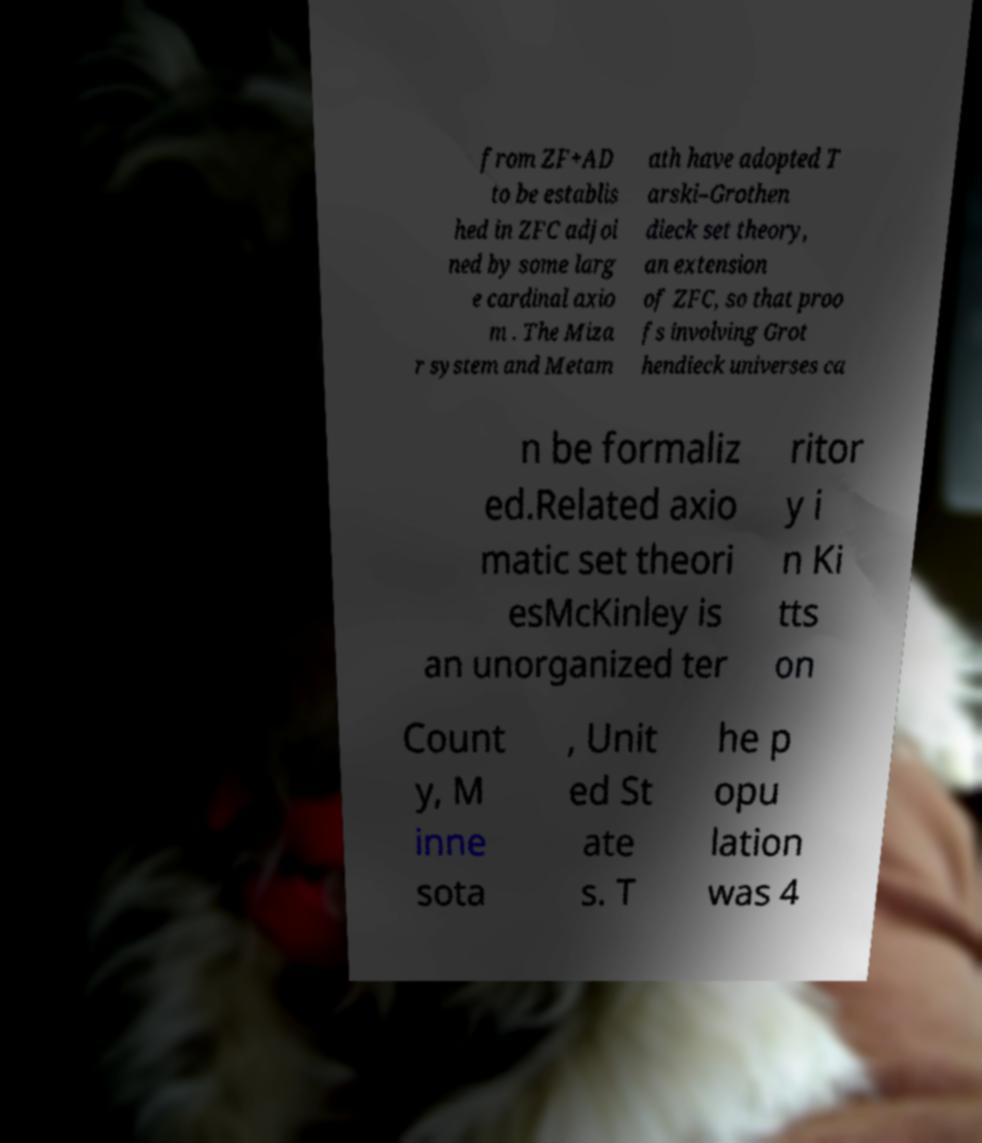Can you accurately transcribe the text from the provided image for me? from ZF+AD to be establis hed in ZFC adjoi ned by some larg e cardinal axio m . The Miza r system and Metam ath have adopted T arski–Grothen dieck set theory, an extension of ZFC, so that proo fs involving Grot hendieck universes ca n be formaliz ed.Related axio matic set theori esMcKinley is an unorganized ter ritor y i n Ki tts on Count y, M inne sota , Unit ed St ate s. T he p opu lation was 4 